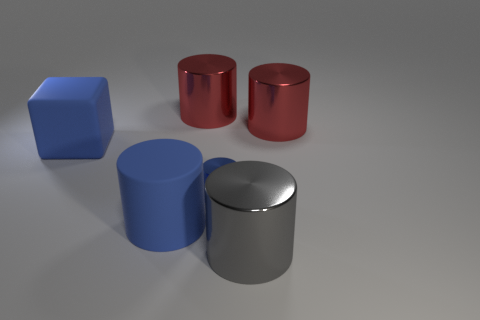What number of things are either big red metal things that are to the right of the small blue thing or large yellow rubber objects?
Provide a short and direct response. 1. What number of other things are there of the same color as the rubber cylinder?
Your answer should be compact. 2. Is the color of the large block the same as the object that is on the right side of the big gray cylinder?
Make the answer very short. No. The big rubber object that is the same shape as the tiny metallic object is what color?
Your response must be concise. Blue. Is the material of the small object the same as the red thing that is on the right side of the tiny blue metal cylinder?
Provide a succinct answer. Yes. The tiny shiny object is what color?
Ensure brevity in your answer.  Blue. There is a matte thing to the right of the big blue object that is behind the tiny thing that is right of the large blue cylinder; what is its color?
Your answer should be compact. Blue. Does the small blue object have the same shape as the object left of the big blue cylinder?
Your answer should be very brief. No. What is the color of the large thing that is behind the big matte block and left of the blue metal cylinder?
Offer a very short reply. Red. Is there another purple object that has the same shape as the tiny object?
Your answer should be compact. No. 